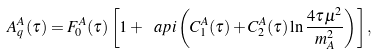Convert formula to latex. <formula><loc_0><loc_0><loc_500><loc_500>A _ { q } ^ { A } ( \tau ) = F _ { 0 } ^ { A } ( \tau ) \left [ 1 + \ a p i \left ( C _ { 1 } ^ { A } ( \tau ) + C _ { 2 } ^ { A } ( \tau ) \ln \frac { 4 \tau \mu ^ { 2 } } { m _ { A } ^ { 2 } } \right ) \right ] ,</formula> 